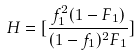<formula> <loc_0><loc_0><loc_500><loc_500>H = [ \frac { f _ { 1 } ^ { 2 } ( 1 - F _ { 1 } ) } { ( 1 - f _ { 1 } ) ^ { 2 } F _ { 1 } } ]</formula> 